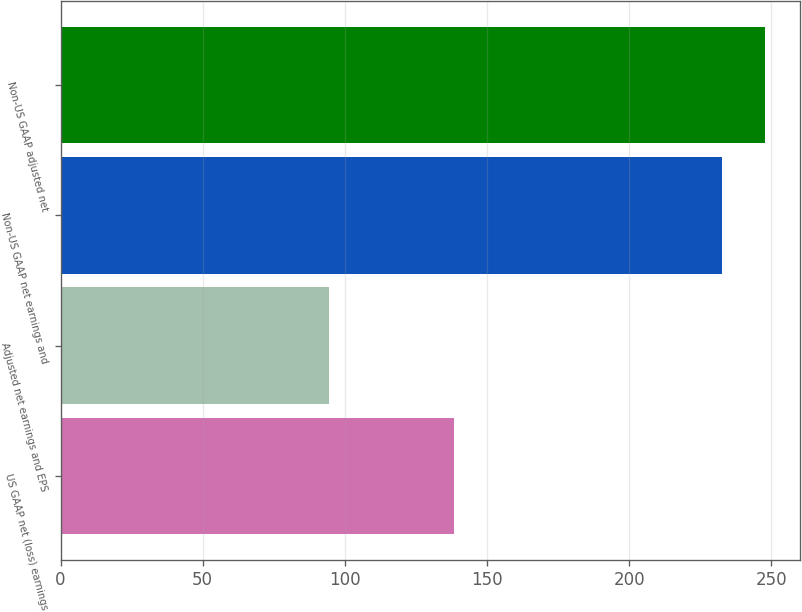<chart> <loc_0><loc_0><loc_500><loc_500><bar_chart><fcel>US GAAP net (loss) earnings<fcel>Adjusted net earnings and EPS<fcel>Non-US GAAP net earnings and<fcel>Non-US GAAP adjusted net<nl><fcel>138.5<fcel>94.3<fcel>232.8<fcel>247.71<nl></chart> 